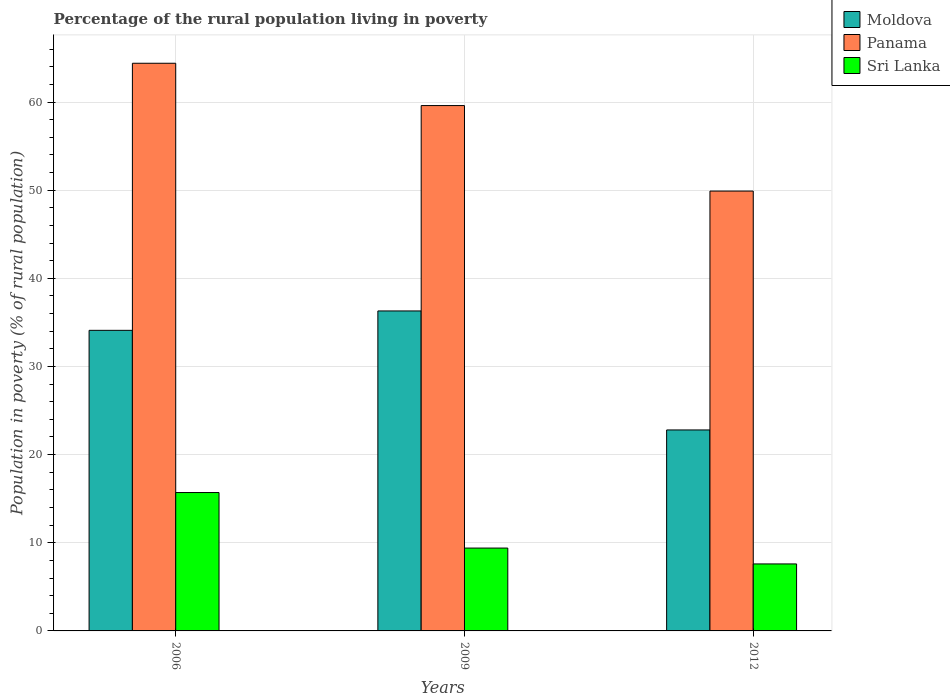How many groups of bars are there?
Your answer should be compact. 3. Are the number of bars per tick equal to the number of legend labels?
Ensure brevity in your answer.  Yes. Are the number of bars on each tick of the X-axis equal?
Provide a succinct answer. Yes. How many bars are there on the 2nd tick from the right?
Ensure brevity in your answer.  3. What is the percentage of the rural population living in poverty in Moldova in 2006?
Keep it short and to the point. 34.1. In which year was the percentage of the rural population living in poverty in Panama maximum?
Your answer should be very brief. 2006. In which year was the percentage of the rural population living in poverty in Panama minimum?
Ensure brevity in your answer.  2012. What is the total percentage of the rural population living in poverty in Moldova in the graph?
Offer a very short reply. 93.2. What is the difference between the percentage of the rural population living in poverty in Panama in 2009 and that in 2012?
Provide a short and direct response. 9.7. What is the difference between the percentage of the rural population living in poverty in Panama in 2012 and the percentage of the rural population living in poverty in Moldova in 2006?
Offer a very short reply. 15.8. What is the average percentage of the rural population living in poverty in Panama per year?
Ensure brevity in your answer.  57.97. In the year 2006, what is the difference between the percentage of the rural population living in poverty in Panama and percentage of the rural population living in poverty in Sri Lanka?
Provide a succinct answer. 48.7. What is the ratio of the percentage of the rural population living in poverty in Panama in 2009 to that in 2012?
Your answer should be compact. 1.19. Is the difference between the percentage of the rural population living in poverty in Panama in 2006 and 2009 greater than the difference between the percentage of the rural population living in poverty in Sri Lanka in 2006 and 2009?
Provide a short and direct response. No. What is the difference between the highest and the second highest percentage of the rural population living in poverty in Moldova?
Your response must be concise. 2.2. What is the difference between the highest and the lowest percentage of the rural population living in poverty in Moldova?
Keep it short and to the point. 13.5. What does the 2nd bar from the left in 2006 represents?
Your answer should be compact. Panama. What does the 3rd bar from the right in 2012 represents?
Keep it short and to the point. Moldova. Is it the case that in every year, the sum of the percentage of the rural population living in poverty in Sri Lanka and percentage of the rural population living in poverty in Moldova is greater than the percentage of the rural population living in poverty in Panama?
Keep it short and to the point. No. Are all the bars in the graph horizontal?
Give a very brief answer. No. Are the values on the major ticks of Y-axis written in scientific E-notation?
Ensure brevity in your answer.  No. Does the graph contain any zero values?
Give a very brief answer. No. Does the graph contain grids?
Your answer should be very brief. Yes. Where does the legend appear in the graph?
Give a very brief answer. Top right. How many legend labels are there?
Offer a terse response. 3. How are the legend labels stacked?
Ensure brevity in your answer.  Vertical. What is the title of the graph?
Keep it short and to the point. Percentage of the rural population living in poverty. Does "Tonga" appear as one of the legend labels in the graph?
Offer a terse response. No. What is the label or title of the X-axis?
Keep it short and to the point. Years. What is the label or title of the Y-axis?
Provide a succinct answer. Population in poverty (% of rural population). What is the Population in poverty (% of rural population) in Moldova in 2006?
Your response must be concise. 34.1. What is the Population in poverty (% of rural population) of Panama in 2006?
Your answer should be very brief. 64.4. What is the Population in poverty (% of rural population) of Moldova in 2009?
Provide a succinct answer. 36.3. What is the Population in poverty (% of rural population) in Panama in 2009?
Provide a succinct answer. 59.6. What is the Population in poverty (% of rural population) of Sri Lanka in 2009?
Provide a succinct answer. 9.4. What is the Population in poverty (% of rural population) of Moldova in 2012?
Ensure brevity in your answer.  22.8. What is the Population in poverty (% of rural population) in Panama in 2012?
Offer a terse response. 49.9. Across all years, what is the maximum Population in poverty (% of rural population) of Moldova?
Offer a terse response. 36.3. Across all years, what is the maximum Population in poverty (% of rural population) of Panama?
Give a very brief answer. 64.4. Across all years, what is the maximum Population in poverty (% of rural population) in Sri Lanka?
Provide a short and direct response. 15.7. Across all years, what is the minimum Population in poverty (% of rural population) in Moldova?
Provide a short and direct response. 22.8. Across all years, what is the minimum Population in poverty (% of rural population) of Panama?
Offer a terse response. 49.9. What is the total Population in poverty (% of rural population) of Moldova in the graph?
Give a very brief answer. 93.2. What is the total Population in poverty (% of rural population) in Panama in the graph?
Provide a succinct answer. 173.9. What is the total Population in poverty (% of rural population) of Sri Lanka in the graph?
Your answer should be very brief. 32.7. What is the difference between the Population in poverty (% of rural population) of Moldova in 2006 and that in 2009?
Your answer should be compact. -2.2. What is the difference between the Population in poverty (% of rural population) in Sri Lanka in 2006 and that in 2009?
Provide a short and direct response. 6.3. What is the difference between the Population in poverty (% of rural population) of Sri Lanka in 2006 and that in 2012?
Provide a succinct answer. 8.1. What is the difference between the Population in poverty (% of rural population) in Moldova in 2009 and that in 2012?
Your response must be concise. 13.5. What is the difference between the Population in poverty (% of rural population) in Panama in 2009 and that in 2012?
Your response must be concise. 9.7. What is the difference between the Population in poverty (% of rural population) in Moldova in 2006 and the Population in poverty (% of rural population) in Panama in 2009?
Offer a terse response. -25.5. What is the difference between the Population in poverty (% of rural population) of Moldova in 2006 and the Population in poverty (% of rural population) of Sri Lanka in 2009?
Offer a terse response. 24.7. What is the difference between the Population in poverty (% of rural population) of Moldova in 2006 and the Population in poverty (% of rural population) of Panama in 2012?
Ensure brevity in your answer.  -15.8. What is the difference between the Population in poverty (% of rural population) of Panama in 2006 and the Population in poverty (% of rural population) of Sri Lanka in 2012?
Provide a short and direct response. 56.8. What is the difference between the Population in poverty (% of rural population) of Moldova in 2009 and the Population in poverty (% of rural population) of Panama in 2012?
Keep it short and to the point. -13.6. What is the difference between the Population in poverty (% of rural population) of Moldova in 2009 and the Population in poverty (% of rural population) of Sri Lanka in 2012?
Provide a short and direct response. 28.7. What is the difference between the Population in poverty (% of rural population) of Panama in 2009 and the Population in poverty (% of rural population) of Sri Lanka in 2012?
Your answer should be very brief. 52. What is the average Population in poverty (% of rural population) of Moldova per year?
Keep it short and to the point. 31.07. What is the average Population in poverty (% of rural population) of Panama per year?
Give a very brief answer. 57.97. In the year 2006, what is the difference between the Population in poverty (% of rural population) of Moldova and Population in poverty (% of rural population) of Panama?
Offer a very short reply. -30.3. In the year 2006, what is the difference between the Population in poverty (% of rural population) of Panama and Population in poverty (% of rural population) of Sri Lanka?
Keep it short and to the point. 48.7. In the year 2009, what is the difference between the Population in poverty (% of rural population) of Moldova and Population in poverty (% of rural population) of Panama?
Your response must be concise. -23.3. In the year 2009, what is the difference between the Population in poverty (% of rural population) in Moldova and Population in poverty (% of rural population) in Sri Lanka?
Keep it short and to the point. 26.9. In the year 2009, what is the difference between the Population in poverty (% of rural population) in Panama and Population in poverty (% of rural population) in Sri Lanka?
Give a very brief answer. 50.2. In the year 2012, what is the difference between the Population in poverty (% of rural population) in Moldova and Population in poverty (% of rural population) in Panama?
Your answer should be compact. -27.1. In the year 2012, what is the difference between the Population in poverty (% of rural population) of Panama and Population in poverty (% of rural population) of Sri Lanka?
Your response must be concise. 42.3. What is the ratio of the Population in poverty (% of rural population) of Moldova in 2006 to that in 2009?
Your response must be concise. 0.94. What is the ratio of the Population in poverty (% of rural population) of Panama in 2006 to that in 2009?
Ensure brevity in your answer.  1.08. What is the ratio of the Population in poverty (% of rural population) in Sri Lanka in 2006 to that in 2009?
Provide a short and direct response. 1.67. What is the ratio of the Population in poverty (% of rural population) in Moldova in 2006 to that in 2012?
Give a very brief answer. 1.5. What is the ratio of the Population in poverty (% of rural population) of Panama in 2006 to that in 2012?
Your answer should be very brief. 1.29. What is the ratio of the Population in poverty (% of rural population) in Sri Lanka in 2006 to that in 2012?
Offer a terse response. 2.07. What is the ratio of the Population in poverty (% of rural population) of Moldova in 2009 to that in 2012?
Offer a very short reply. 1.59. What is the ratio of the Population in poverty (% of rural population) in Panama in 2009 to that in 2012?
Offer a terse response. 1.19. What is the ratio of the Population in poverty (% of rural population) of Sri Lanka in 2009 to that in 2012?
Keep it short and to the point. 1.24. What is the difference between the highest and the second highest Population in poverty (% of rural population) in Moldova?
Offer a very short reply. 2.2. What is the difference between the highest and the lowest Population in poverty (% of rural population) of Moldova?
Keep it short and to the point. 13.5. What is the difference between the highest and the lowest Population in poverty (% of rural population) in Panama?
Keep it short and to the point. 14.5. 